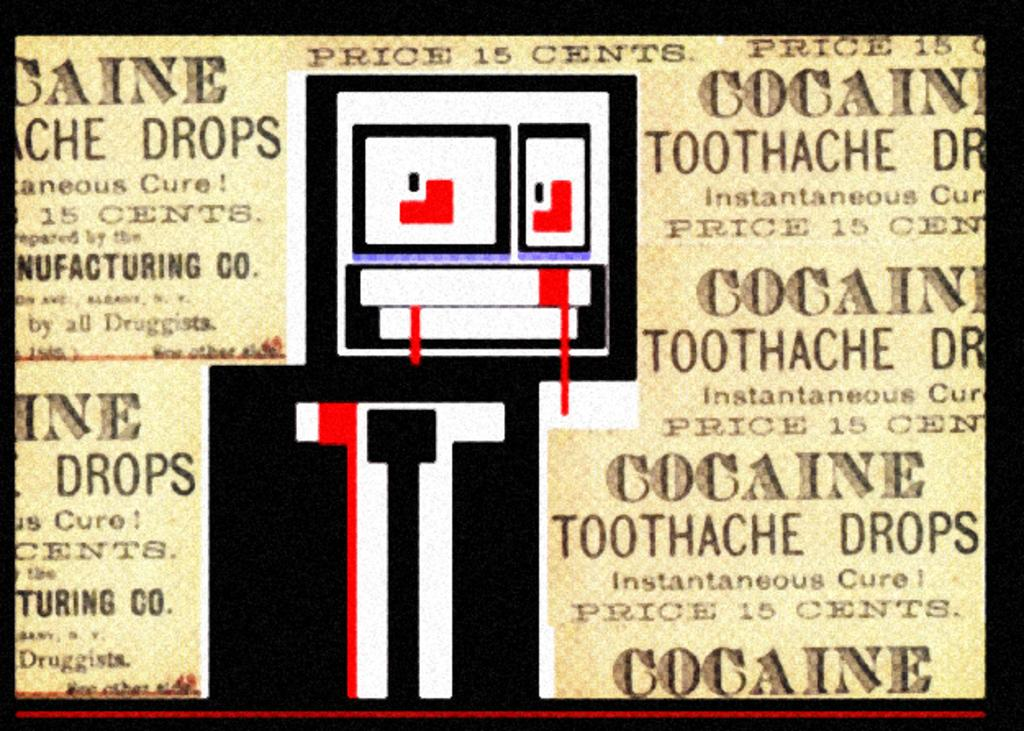What is the color of the text in the image? The text in the image is written in black color. What can be found in the middle of the image? There are designs in the middle of the image. What word is the writer trying to convey in the image? There is no writer or specific word mentioned in the image; it only contains text and designs. 